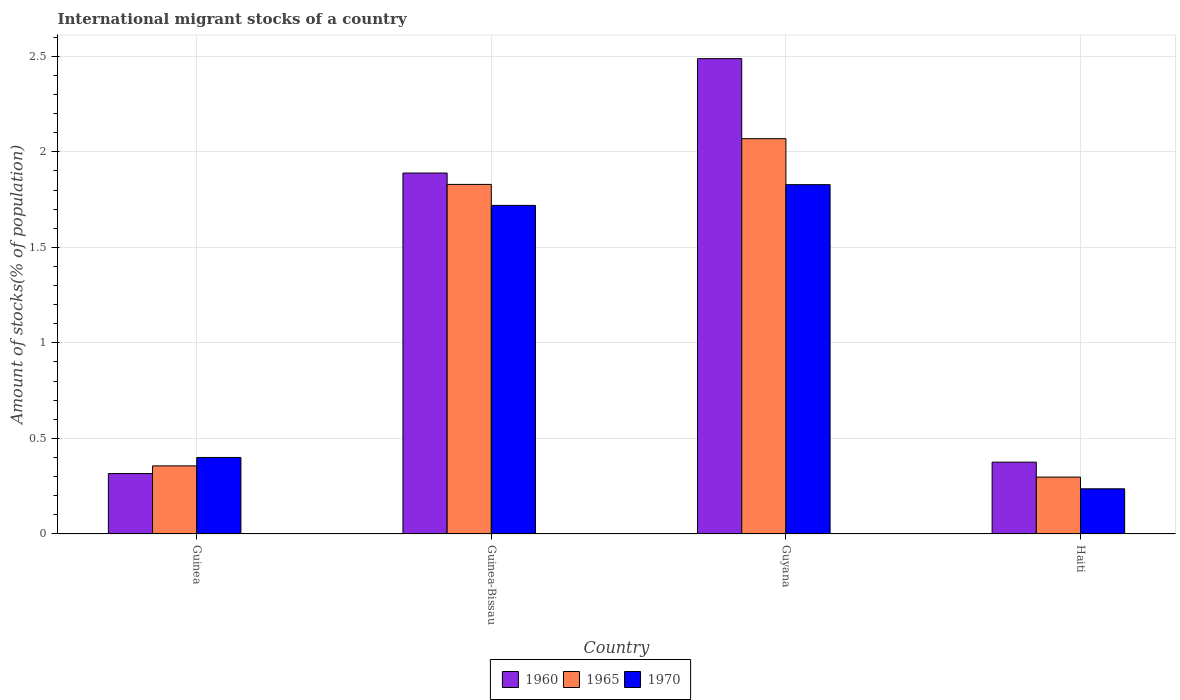How many different coloured bars are there?
Offer a very short reply. 3. How many groups of bars are there?
Give a very brief answer. 4. Are the number of bars per tick equal to the number of legend labels?
Provide a succinct answer. Yes. How many bars are there on the 1st tick from the left?
Offer a very short reply. 3. What is the label of the 1st group of bars from the left?
Your response must be concise. Guinea. What is the amount of stocks in in 1965 in Guinea-Bissau?
Your answer should be very brief. 1.83. Across all countries, what is the maximum amount of stocks in in 1970?
Your answer should be very brief. 1.83. Across all countries, what is the minimum amount of stocks in in 1960?
Your response must be concise. 0.32. In which country was the amount of stocks in in 1970 maximum?
Provide a short and direct response. Guyana. In which country was the amount of stocks in in 1965 minimum?
Give a very brief answer. Haiti. What is the total amount of stocks in in 1960 in the graph?
Offer a terse response. 5.07. What is the difference between the amount of stocks in in 1960 in Guinea and that in Haiti?
Make the answer very short. -0.06. What is the difference between the amount of stocks in in 1960 in Guinea and the amount of stocks in in 1965 in Guyana?
Provide a short and direct response. -1.75. What is the average amount of stocks in in 1960 per country?
Offer a very short reply. 1.27. What is the difference between the amount of stocks in of/in 1960 and amount of stocks in of/in 1970 in Guinea-Bissau?
Offer a terse response. 0.17. What is the ratio of the amount of stocks in in 1970 in Guinea to that in Haiti?
Your answer should be very brief. 1.69. What is the difference between the highest and the second highest amount of stocks in in 1960?
Make the answer very short. -1.51. What is the difference between the highest and the lowest amount of stocks in in 1970?
Ensure brevity in your answer.  1.59. In how many countries, is the amount of stocks in in 1965 greater than the average amount of stocks in in 1965 taken over all countries?
Give a very brief answer. 2. What does the 2nd bar from the left in Guinea-Bissau represents?
Make the answer very short. 1965. What does the 2nd bar from the right in Guinea represents?
Give a very brief answer. 1965. What is the difference between two consecutive major ticks on the Y-axis?
Make the answer very short. 0.5. Are the values on the major ticks of Y-axis written in scientific E-notation?
Your answer should be very brief. No. Does the graph contain any zero values?
Your response must be concise. No. Does the graph contain grids?
Your answer should be compact. Yes. How are the legend labels stacked?
Your response must be concise. Horizontal. What is the title of the graph?
Keep it short and to the point. International migrant stocks of a country. What is the label or title of the Y-axis?
Offer a very short reply. Amount of stocks(% of population). What is the Amount of stocks(% of population) in 1960 in Guinea?
Provide a short and direct response. 0.32. What is the Amount of stocks(% of population) in 1965 in Guinea?
Make the answer very short. 0.36. What is the Amount of stocks(% of population) of 1970 in Guinea?
Ensure brevity in your answer.  0.4. What is the Amount of stocks(% of population) of 1960 in Guinea-Bissau?
Your answer should be compact. 1.89. What is the Amount of stocks(% of population) of 1965 in Guinea-Bissau?
Ensure brevity in your answer.  1.83. What is the Amount of stocks(% of population) in 1970 in Guinea-Bissau?
Your answer should be very brief. 1.72. What is the Amount of stocks(% of population) of 1960 in Guyana?
Give a very brief answer. 2.49. What is the Amount of stocks(% of population) in 1965 in Guyana?
Give a very brief answer. 2.07. What is the Amount of stocks(% of population) in 1970 in Guyana?
Provide a short and direct response. 1.83. What is the Amount of stocks(% of population) in 1960 in Haiti?
Offer a terse response. 0.38. What is the Amount of stocks(% of population) in 1965 in Haiti?
Provide a short and direct response. 0.3. What is the Amount of stocks(% of population) of 1970 in Haiti?
Keep it short and to the point. 0.24. Across all countries, what is the maximum Amount of stocks(% of population) of 1960?
Make the answer very short. 2.49. Across all countries, what is the maximum Amount of stocks(% of population) in 1965?
Make the answer very short. 2.07. Across all countries, what is the maximum Amount of stocks(% of population) of 1970?
Your answer should be compact. 1.83. Across all countries, what is the minimum Amount of stocks(% of population) of 1960?
Your answer should be very brief. 0.32. Across all countries, what is the minimum Amount of stocks(% of population) of 1965?
Offer a very short reply. 0.3. Across all countries, what is the minimum Amount of stocks(% of population) in 1970?
Offer a very short reply. 0.24. What is the total Amount of stocks(% of population) of 1960 in the graph?
Provide a short and direct response. 5.07. What is the total Amount of stocks(% of population) in 1965 in the graph?
Give a very brief answer. 4.55. What is the total Amount of stocks(% of population) of 1970 in the graph?
Offer a very short reply. 4.18. What is the difference between the Amount of stocks(% of population) of 1960 in Guinea and that in Guinea-Bissau?
Keep it short and to the point. -1.57. What is the difference between the Amount of stocks(% of population) of 1965 in Guinea and that in Guinea-Bissau?
Your answer should be compact. -1.47. What is the difference between the Amount of stocks(% of population) in 1970 in Guinea and that in Guinea-Bissau?
Your answer should be compact. -1.32. What is the difference between the Amount of stocks(% of population) in 1960 in Guinea and that in Guyana?
Provide a short and direct response. -2.17. What is the difference between the Amount of stocks(% of population) of 1965 in Guinea and that in Guyana?
Your answer should be very brief. -1.71. What is the difference between the Amount of stocks(% of population) of 1970 in Guinea and that in Guyana?
Your answer should be compact. -1.43. What is the difference between the Amount of stocks(% of population) of 1960 in Guinea and that in Haiti?
Your answer should be very brief. -0.06. What is the difference between the Amount of stocks(% of population) in 1965 in Guinea and that in Haiti?
Offer a terse response. 0.06. What is the difference between the Amount of stocks(% of population) in 1970 in Guinea and that in Haiti?
Offer a very short reply. 0.16. What is the difference between the Amount of stocks(% of population) in 1960 in Guinea-Bissau and that in Guyana?
Give a very brief answer. -0.6. What is the difference between the Amount of stocks(% of population) of 1965 in Guinea-Bissau and that in Guyana?
Ensure brevity in your answer.  -0.24. What is the difference between the Amount of stocks(% of population) in 1970 in Guinea-Bissau and that in Guyana?
Provide a succinct answer. -0.11. What is the difference between the Amount of stocks(% of population) in 1960 in Guinea-Bissau and that in Haiti?
Your answer should be very brief. 1.51. What is the difference between the Amount of stocks(% of population) in 1965 in Guinea-Bissau and that in Haiti?
Your response must be concise. 1.53. What is the difference between the Amount of stocks(% of population) in 1970 in Guinea-Bissau and that in Haiti?
Offer a very short reply. 1.48. What is the difference between the Amount of stocks(% of population) of 1960 in Guyana and that in Haiti?
Make the answer very short. 2.11. What is the difference between the Amount of stocks(% of population) in 1965 in Guyana and that in Haiti?
Provide a short and direct response. 1.77. What is the difference between the Amount of stocks(% of population) in 1970 in Guyana and that in Haiti?
Make the answer very short. 1.59. What is the difference between the Amount of stocks(% of population) in 1960 in Guinea and the Amount of stocks(% of population) in 1965 in Guinea-Bissau?
Give a very brief answer. -1.51. What is the difference between the Amount of stocks(% of population) of 1960 in Guinea and the Amount of stocks(% of population) of 1970 in Guinea-Bissau?
Make the answer very short. -1.4. What is the difference between the Amount of stocks(% of population) of 1965 in Guinea and the Amount of stocks(% of population) of 1970 in Guinea-Bissau?
Your answer should be compact. -1.36. What is the difference between the Amount of stocks(% of population) of 1960 in Guinea and the Amount of stocks(% of population) of 1965 in Guyana?
Make the answer very short. -1.75. What is the difference between the Amount of stocks(% of population) of 1960 in Guinea and the Amount of stocks(% of population) of 1970 in Guyana?
Make the answer very short. -1.51. What is the difference between the Amount of stocks(% of population) in 1965 in Guinea and the Amount of stocks(% of population) in 1970 in Guyana?
Provide a short and direct response. -1.47. What is the difference between the Amount of stocks(% of population) of 1960 in Guinea and the Amount of stocks(% of population) of 1965 in Haiti?
Offer a terse response. 0.02. What is the difference between the Amount of stocks(% of population) in 1960 in Guinea and the Amount of stocks(% of population) in 1970 in Haiti?
Your response must be concise. 0.08. What is the difference between the Amount of stocks(% of population) of 1965 in Guinea and the Amount of stocks(% of population) of 1970 in Haiti?
Give a very brief answer. 0.12. What is the difference between the Amount of stocks(% of population) in 1960 in Guinea-Bissau and the Amount of stocks(% of population) in 1965 in Guyana?
Make the answer very short. -0.18. What is the difference between the Amount of stocks(% of population) in 1960 in Guinea-Bissau and the Amount of stocks(% of population) in 1970 in Guyana?
Offer a very short reply. 0.06. What is the difference between the Amount of stocks(% of population) of 1965 in Guinea-Bissau and the Amount of stocks(% of population) of 1970 in Guyana?
Provide a succinct answer. 0. What is the difference between the Amount of stocks(% of population) in 1960 in Guinea-Bissau and the Amount of stocks(% of population) in 1965 in Haiti?
Your answer should be compact. 1.59. What is the difference between the Amount of stocks(% of population) in 1960 in Guinea-Bissau and the Amount of stocks(% of population) in 1970 in Haiti?
Provide a succinct answer. 1.65. What is the difference between the Amount of stocks(% of population) in 1965 in Guinea-Bissau and the Amount of stocks(% of population) in 1970 in Haiti?
Provide a short and direct response. 1.59. What is the difference between the Amount of stocks(% of population) of 1960 in Guyana and the Amount of stocks(% of population) of 1965 in Haiti?
Give a very brief answer. 2.19. What is the difference between the Amount of stocks(% of population) in 1960 in Guyana and the Amount of stocks(% of population) in 1970 in Haiti?
Your answer should be very brief. 2.25. What is the difference between the Amount of stocks(% of population) in 1965 in Guyana and the Amount of stocks(% of population) in 1970 in Haiti?
Give a very brief answer. 1.83. What is the average Amount of stocks(% of population) of 1960 per country?
Your answer should be very brief. 1.27. What is the average Amount of stocks(% of population) in 1965 per country?
Keep it short and to the point. 1.14. What is the average Amount of stocks(% of population) of 1970 per country?
Ensure brevity in your answer.  1.05. What is the difference between the Amount of stocks(% of population) of 1960 and Amount of stocks(% of population) of 1965 in Guinea?
Offer a terse response. -0.04. What is the difference between the Amount of stocks(% of population) of 1960 and Amount of stocks(% of population) of 1970 in Guinea?
Give a very brief answer. -0.08. What is the difference between the Amount of stocks(% of population) of 1965 and Amount of stocks(% of population) of 1970 in Guinea?
Ensure brevity in your answer.  -0.04. What is the difference between the Amount of stocks(% of population) in 1960 and Amount of stocks(% of population) in 1965 in Guinea-Bissau?
Your answer should be very brief. 0.06. What is the difference between the Amount of stocks(% of population) in 1960 and Amount of stocks(% of population) in 1970 in Guinea-Bissau?
Ensure brevity in your answer.  0.17. What is the difference between the Amount of stocks(% of population) in 1965 and Amount of stocks(% of population) in 1970 in Guinea-Bissau?
Your answer should be very brief. 0.11. What is the difference between the Amount of stocks(% of population) of 1960 and Amount of stocks(% of population) of 1965 in Guyana?
Ensure brevity in your answer.  0.42. What is the difference between the Amount of stocks(% of population) in 1960 and Amount of stocks(% of population) in 1970 in Guyana?
Make the answer very short. 0.66. What is the difference between the Amount of stocks(% of population) of 1965 and Amount of stocks(% of population) of 1970 in Guyana?
Give a very brief answer. 0.24. What is the difference between the Amount of stocks(% of population) of 1960 and Amount of stocks(% of population) of 1965 in Haiti?
Provide a short and direct response. 0.08. What is the difference between the Amount of stocks(% of population) of 1960 and Amount of stocks(% of population) of 1970 in Haiti?
Give a very brief answer. 0.14. What is the difference between the Amount of stocks(% of population) in 1965 and Amount of stocks(% of population) in 1970 in Haiti?
Provide a succinct answer. 0.06. What is the ratio of the Amount of stocks(% of population) of 1960 in Guinea to that in Guinea-Bissau?
Your answer should be compact. 0.17. What is the ratio of the Amount of stocks(% of population) in 1965 in Guinea to that in Guinea-Bissau?
Make the answer very short. 0.19. What is the ratio of the Amount of stocks(% of population) of 1970 in Guinea to that in Guinea-Bissau?
Offer a very short reply. 0.23. What is the ratio of the Amount of stocks(% of population) of 1960 in Guinea to that in Guyana?
Give a very brief answer. 0.13. What is the ratio of the Amount of stocks(% of population) in 1965 in Guinea to that in Guyana?
Offer a very short reply. 0.17. What is the ratio of the Amount of stocks(% of population) of 1970 in Guinea to that in Guyana?
Offer a very short reply. 0.22. What is the ratio of the Amount of stocks(% of population) of 1960 in Guinea to that in Haiti?
Provide a short and direct response. 0.84. What is the ratio of the Amount of stocks(% of population) of 1965 in Guinea to that in Haiti?
Make the answer very short. 1.2. What is the ratio of the Amount of stocks(% of population) of 1970 in Guinea to that in Haiti?
Offer a very short reply. 1.69. What is the ratio of the Amount of stocks(% of population) in 1960 in Guinea-Bissau to that in Guyana?
Your answer should be compact. 0.76. What is the ratio of the Amount of stocks(% of population) of 1965 in Guinea-Bissau to that in Guyana?
Offer a terse response. 0.88. What is the ratio of the Amount of stocks(% of population) of 1970 in Guinea-Bissau to that in Guyana?
Make the answer very short. 0.94. What is the ratio of the Amount of stocks(% of population) of 1960 in Guinea-Bissau to that in Haiti?
Give a very brief answer. 5.02. What is the ratio of the Amount of stocks(% of population) of 1965 in Guinea-Bissau to that in Haiti?
Make the answer very short. 6.14. What is the ratio of the Amount of stocks(% of population) in 1970 in Guinea-Bissau to that in Haiti?
Ensure brevity in your answer.  7.28. What is the ratio of the Amount of stocks(% of population) of 1960 in Guyana to that in Haiti?
Give a very brief answer. 6.62. What is the ratio of the Amount of stocks(% of population) of 1965 in Guyana to that in Haiti?
Provide a short and direct response. 6.95. What is the ratio of the Amount of stocks(% of population) in 1970 in Guyana to that in Haiti?
Offer a very short reply. 7.73. What is the difference between the highest and the second highest Amount of stocks(% of population) in 1960?
Provide a succinct answer. 0.6. What is the difference between the highest and the second highest Amount of stocks(% of population) in 1965?
Offer a very short reply. 0.24. What is the difference between the highest and the second highest Amount of stocks(% of population) of 1970?
Make the answer very short. 0.11. What is the difference between the highest and the lowest Amount of stocks(% of population) of 1960?
Your answer should be compact. 2.17. What is the difference between the highest and the lowest Amount of stocks(% of population) of 1965?
Give a very brief answer. 1.77. What is the difference between the highest and the lowest Amount of stocks(% of population) in 1970?
Offer a terse response. 1.59. 